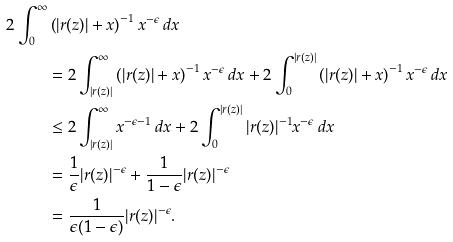<formula> <loc_0><loc_0><loc_500><loc_500>2 \int _ { 0 } ^ { \infty } & \left ( | r ( z ) | + x \right ) ^ { - 1 } x ^ { - \epsilon } \, d x \\ & = 2 \int _ { | r ( z ) | } ^ { \infty } \left ( | r ( z ) | + x \right ) ^ { - 1 } x ^ { - \epsilon } \, d x + 2 \int _ { 0 } ^ { | r ( z ) | } \left ( | r ( z ) | + x \right ) ^ { - 1 } x ^ { - \epsilon } \, d x \\ & \leq 2 \int _ { | r ( z ) | } ^ { \infty } x ^ { - \epsilon - 1 } \, d x + 2 \int _ { 0 } ^ { | r ( z ) | } | r ( z ) | ^ { - 1 } x ^ { - \epsilon } \, d x \\ & = \frac { 1 } { \epsilon } | r ( z ) | ^ { - \epsilon } + \frac { 1 } { 1 - \epsilon } | r ( z ) | ^ { - \epsilon } \\ & = \frac { 1 } { \epsilon ( 1 - \epsilon ) } | r ( z ) | ^ { - \epsilon } . \\</formula> 